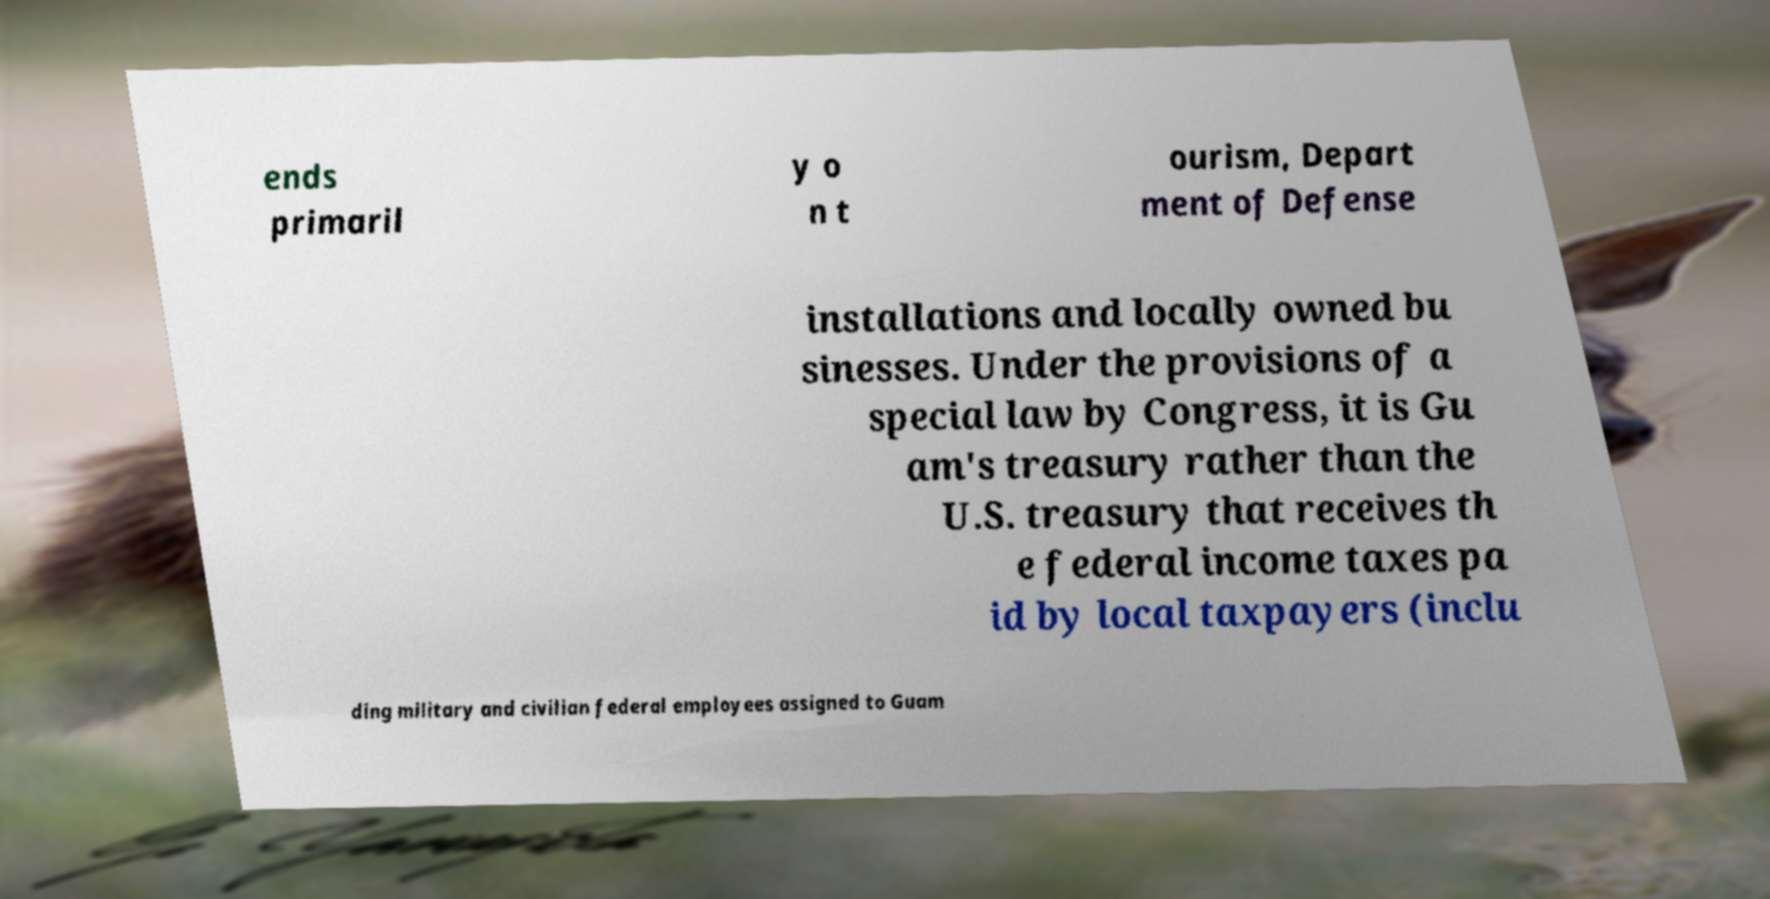Could you extract and type out the text from this image? ends primaril y o n t ourism, Depart ment of Defense installations and locally owned bu sinesses. Under the provisions of a special law by Congress, it is Gu am's treasury rather than the U.S. treasury that receives th e federal income taxes pa id by local taxpayers (inclu ding military and civilian federal employees assigned to Guam 